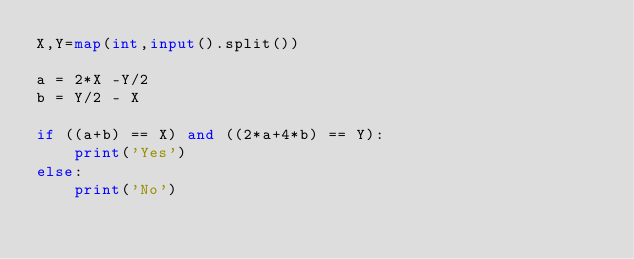Convert code to text. <code><loc_0><loc_0><loc_500><loc_500><_Python_>X,Y=map(int,input().split())

a = 2*X -Y/2
b = Y/2 - X

if ((a+b) == X) and ((2*a+4*b) == Y):
    print('Yes')
else:
    print('No')	
</code> 